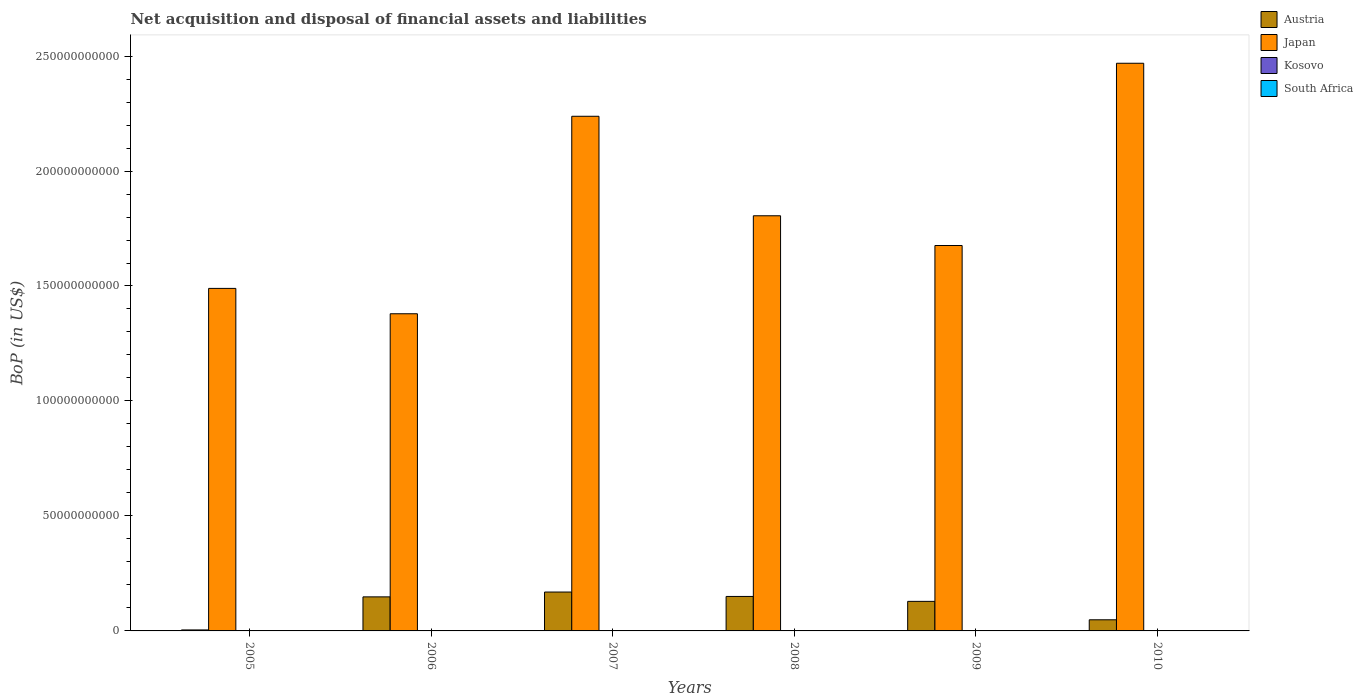How many groups of bars are there?
Give a very brief answer. 6. How many bars are there on the 3rd tick from the right?
Offer a very short reply. 2. What is the Balance of Payments in Japan in 2005?
Make the answer very short. 1.49e+11. Across all years, what is the maximum Balance of Payments in Austria?
Your response must be concise. 1.69e+1. Across all years, what is the minimum Balance of Payments in South Africa?
Provide a short and direct response. 0. In which year was the Balance of Payments in Austria maximum?
Make the answer very short. 2007. What is the total Balance of Payments in Kosovo in the graph?
Make the answer very short. 4.48e+07. What is the difference between the Balance of Payments in Japan in 2005 and that in 2009?
Your response must be concise. -1.87e+1. What is the difference between the Balance of Payments in Kosovo in 2008 and the Balance of Payments in Japan in 2006?
Your response must be concise. -1.38e+11. In the year 2006, what is the difference between the Balance of Payments in Austria and Balance of Payments in Kosovo?
Offer a very short reply. 1.48e+1. In how many years, is the Balance of Payments in Japan greater than 160000000000 US$?
Give a very brief answer. 4. What is the ratio of the Balance of Payments in Austria in 2005 to that in 2010?
Your answer should be very brief. 0.09. What is the difference between the highest and the second highest Balance of Payments in Austria?
Give a very brief answer. 1.92e+09. What is the difference between the highest and the lowest Balance of Payments in Kosovo?
Your answer should be compact. 4.48e+07. In how many years, is the Balance of Payments in Austria greater than the average Balance of Payments in Austria taken over all years?
Your answer should be compact. 4. Is it the case that in every year, the sum of the Balance of Payments in Austria and Balance of Payments in South Africa is greater than the Balance of Payments in Kosovo?
Your response must be concise. Yes. Are all the bars in the graph horizontal?
Give a very brief answer. No. How many years are there in the graph?
Your answer should be very brief. 6. Does the graph contain any zero values?
Make the answer very short. Yes. Does the graph contain grids?
Ensure brevity in your answer.  No. How many legend labels are there?
Provide a succinct answer. 4. What is the title of the graph?
Offer a terse response. Net acquisition and disposal of financial assets and liabilities. What is the label or title of the Y-axis?
Keep it short and to the point. BoP (in US$). What is the BoP (in US$) of Austria in 2005?
Provide a short and direct response. 4.32e+08. What is the BoP (in US$) of Japan in 2005?
Your answer should be very brief. 1.49e+11. What is the BoP (in US$) of South Africa in 2005?
Provide a short and direct response. 0. What is the BoP (in US$) of Austria in 2006?
Provide a succinct answer. 1.48e+1. What is the BoP (in US$) in Japan in 2006?
Your response must be concise. 1.38e+11. What is the BoP (in US$) in Kosovo in 2006?
Your response must be concise. 4.48e+07. What is the BoP (in US$) of South Africa in 2006?
Make the answer very short. 0. What is the BoP (in US$) of Austria in 2007?
Offer a terse response. 1.69e+1. What is the BoP (in US$) in Japan in 2007?
Ensure brevity in your answer.  2.24e+11. What is the BoP (in US$) of South Africa in 2007?
Offer a terse response. 0. What is the BoP (in US$) in Austria in 2008?
Give a very brief answer. 1.50e+1. What is the BoP (in US$) of Japan in 2008?
Offer a terse response. 1.81e+11. What is the BoP (in US$) in Kosovo in 2008?
Ensure brevity in your answer.  0. What is the BoP (in US$) of South Africa in 2008?
Keep it short and to the point. 0. What is the BoP (in US$) of Austria in 2009?
Your answer should be very brief. 1.29e+1. What is the BoP (in US$) in Japan in 2009?
Keep it short and to the point. 1.68e+11. What is the BoP (in US$) of Austria in 2010?
Give a very brief answer. 4.84e+09. What is the BoP (in US$) in Japan in 2010?
Provide a succinct answer. 2.47e+11. What is the BoP (in US$) of Kosovo in 2010?
Provide a succinct answer. 0. Across all years, what is the maximum BoP (in US$) of Austria?
Offer a terse response. 1.69e+1. Across all years, what is the maximum BoP (in US$) of Japan?
Your answer should be very brief. 2.47e+11. Across all years, what is the maximum BoP (in US$) of Kosovo?
Your answer should be very brief. 4.48e+07. Across all years, what is the minimum BoP (in US$) of Austria?
Provide a short and direct response. 4.32e+08. Across all years, what is the minimum BoP (in US$) of Japan?
Your response must be concise. 1.38e+11. Across all years, what is the minimum BoP (in US$) of Kosovo?
Your answer should be very brief. 0. What is the total BoP (in US$) in Austria in the graph?
Your response must be concise. 6.48e+1. What is the total BoP (in US$) of Japan in the graph?
Offer a very short reply. 1.11e+12. What is the total BoP (in US$) of Kosovo in the graph?
Your answer should be very brief. 4.48e+07. What is the difference between the BoP (in US$) of Austria in 2005 and that in 2006?
Offer a very short reply. -1.44e+1. What is the difference between the BoP (in US$) in Japan in 2005 and that in 2006?
Offer a terse response. 1.10e+1. What is the difference between the BoP (in US$) of Austria in 2005 and that in 2007?
Keep it short and to the point. -1.65e+1. What is the difference between the BoP (in US$) in Japan in 2005 and that in 2007?
Keep it short and to the point. -7.49e+1. What is the difference between the BoP (in US$) in Austria in 2005 and that in 2008?
Keep it short and to the point. -1.46e+1. What is the difference between the BoP (in US$) in Japan in 2005 and that in 2008?
Make the answer very short. -3.16e+1. What is the difference between the BoP (in US$) in Austria in 2005 and that in 2009?
Offer a terse response. -1.24e+1. What is the difference between the BoP (in US$) of Japan in 2005 and that in 2009?
Your answer should be compact. -1.87e+1. What is the difference between the BoP (in US$) of Austria in 2005 and that in 2010?
Offer a terse response. -4.41e+09. What is the difference between the BoP (in US$) of Japan in 2005 and that in 2010?
Your answer should be very brief. -9.79e+1. What is the difference between the BoP (in US$) of Austria in 2006 and that in 2007?
Make the answer very short. -2.10e+09. What is the difference between the BoP (in US$) of Japan in 2006 and that in 2007?
Your answer should be very brief. -8.59e+1. What is the difference between the BoP (in US$) of Austria in 2006 and that in 2008?
Offer a terse response. -1.83e+08. What is the difference between the BoP (in US$) of Japan in 2006 and that in 2008?
Offer a very short reply. -4.26e+1. What is the difference between the BoP (in US$) in Austria in 2006 and that in 2009?
Your response must be concise. 1.96e+09. What is the difference between the BoP (in US$) in Japan in 2006 and that in 2009?
Keep it short and to the point. -2.97e+1. What is the difference between the BoP (in US$) in Austria in 2006 and that in 2010?
Your answer should be very brief. 9.97e+09. What is the difference between the BoP (in US$) in Japan in 2006 and that in 2010?
Provide a succinct answer. -1.09e+11. What is the difference between the BoP (in US$) in Austria in 2007 and that in 2008?
Provide a short and direct response. 1.92e+09. What is the difference between the BoP (in US$) in Japan in 2007 and that in 2008?
Your response must be concise. 4.33e+1. What is the difference between the BoP (in US$) in Austria in 2007 and that in 2009?
Your response must be concise. 4.06e+09. What is the difference between the BoP (in US$) in Japan in 2007 and that in 2009?
Ensure brevity in your answer.  5.62e+1. What is the difference between the BoP (in US$) of Austria in 2007 and that in 2010?
Make the answer very short. 1.21e+1. What is the difference between the BoP (in US$) of Japan in 2007 and that in 2010?
Offer a very short reply. -2.31e+1. What is the difference between the BoP (in US$) in Austria in 2008 and that in 2009?
Offer a very short reply. 2.14e+09. What is the difference between the BoP (in US$) of Japan in 2008 and that in 2009?
Give a very brief answer. 1.29e+1. What is the difference between the BoP (in US$) of Austria in 2008 and that in 2010?
Keep it short and to the point. 1.01e+1. What is the difference between the BoP (in US$) of Japan in 2008 and that in 2010?
Offer a very short reply. -6.63e+1. What is the difference between the BoP (in US$) of Austria in 2009 and that in 2010?
Make the answer very short. 8.01e+09. What is the difference between the BoP (in US$) in Japan in 2009 and that in 2010?
Your answer should be very brief. -7.93e+1. What is the difference between the BoP (in US$) of Austria in 2005 and the BoP (in US$) of Japan in 2006?
Offer a terse response. -1.37e+11. What is the difference between the BoP (in US$) in Austria in 2005 and the BoP (in US$) in Kosovo in 2006?
Ensure brevity in your answer.  3.87e+08. What is the difference between the BoP (in US$) in Japan in 2005 and the BoP (in US$) in Kosovo in 2006?
Provide a succinct answer. 1.49e+11. What is the difference between the BoP (in US$) of Austria in 2005 and the BoP (in US$) of Japan in 2007?
Make the answer very short. -2.23e+11. What is the difference between the BoP (in US$) in Austria in 2005 and the BoP (in US$) in Japan in 2008?
Make the answer very short. -1.80e+11. What is the difference between the BoP (in US$) of Austria in 2005 and the BoP (in US$) of Japan in 2009?
Your answer should be compact. -1.67e+11. What is the difference between the BoP (in US$) in Austria in 2005 and the BoP (in US$) in Japan in 2010?
Your response must be concise. -2.46e+11. What is the difference between the BoP (in US$) of Austria in 2006 and the BoP (in US$) of Japan in 2007?
Give a very brief answer. -2.09e+11. What is the difference between the BoP (in US$) in Austria in 2006 and the BoP (in US$) in Japan in 2008?
Offer a very short reply. -1.66e+11. What is the difference between the BoP (in US$) in Austria in 2006 and the BoP (in US$) in Japan in 2009?
Give a very brief answer. -1.53e+11. What is the difference between the BoP (in US$) of Austria in 2006 and the BoP (in US$) of Japan in 2010?
Keep it short and to the point. -2.32e+11. What is the difference between the BoP (in US$) in Austria in 2007 and the BoP (in US$) in Japan in 2008?
Offer a terse response. -1.64e+11. What is the difference between the BoP (in US$) of Austria in 2007 and the BoP (in US$) of Japan in 2009?
Give a very brief answer. -1.51e+11. What is the difference between the BoP (in US$) in Austria in 2007 and the BoP (in US$) in Japan in 2010?
Your answer should be very brief. -2.30e+11. What is the difference between the BoP (in US$) of Austria in 2008 and the BoP (in US$) of Japan in 2009?
Offer a terse response. -1.53e+11. What is the difference between the BoP (in US$) in Austria in 2008 and the BoP (in US$) in Japan in 2010?
Make the answer very short. -2.32e+11. What is the difference between the BoP (in US$) in Austria in 2009 and the BoP (in US$) in Japan in 2010?
Give a very brief answer. -2.34e+11. What is the average BoP (in US$) in Austria per year?
Make the answer very short. 1.08e+1. What is the average BoP (in US$) in Japan per year?
Offer a very short reply. 1.84e+11. What is the average BoP (in US$) in Kosovo per year?
Your answer should be compact. 7.47e+06. What is the average BoP (in US$) of South Africa per year?
Your response must be concise. 0. In the year 2005, what is the difference between the BoP (in US$) in Austria and BoP (in US$) in Japan?
Your answer should be compact. -1.49e+11. In the year 2006, what is the difference between the BoP (in US$) in Austria and BoP (in US$) in Japan?
Provide a succinct answer. -1.23e+11. In the year 2006, what is the difference between the BoP (in US$) of Austria and BoP (in US$) of Kosovo?
Provide a short and direct response. 1.48e+1. In the year 2006, what is the difference between the BoP (in US$) of Japan and BoP (in US$) of Kosovo?
Make the answer very short. 1.38e+11. In the year 2007, what is the difference between the BoP (in US$) of Austria and BoP (in US$) of Japan?
Give a very brief answer. -2.07e+11. In the year 2008, what is the difference between the BoP (in US$) of Austria and BoP (in US$) of Japan?
Give a very brief answer. -1.66e+11. In the year 2009, what is the difference between the BoP (in US$) of Austria and BoP (in US$) of Japan?
Give a very brief answer. -1.55e+11. In the year 2010, what is the difference between the BoP (in US$) of Austria and BoP (in US$) of Japan?
Offer a terse response. -2.42e+11. What is the ratio of the BoP (in US$) of Austria in 2005 to that in 2006?
Make the answer very short. 0.03. What is the ratio of the BoP (in US$) in Japan in 2005 to that in 2006?
Provide a succinct answer. 1.08. What is the ratio of the BoP (in US$) in Austria in 2005 to that in 2007?
Your answer should be very brief. 0.03. What is the ratio of the BoP (in US$) in Japan in 2005 to that in 2007?
Your response must be concise. 0.67. What is the ratio of the BoP (in US$) in Austria in 2005 to that in 2008?
Offer a very short reply. 0.03. What is the ratio of the BoP (in US$) of Japan in 2005 to that in 2008?
Your answer should be compact. 0.83. What is the ratio of the BoP (in US$) in Austria in 2005 to that in 2009?
Give a very brief answer. 0.03. What is the ratio of the BoP (in US$) of Japan in 2005 to that in 2009?
Your response must be concise. 0.89. What is the ratio of the BoP (in US$) in Austria in 2005 to that in 2010?
Your response must be concise. 0.09. What is the ratio of the BoP (in US$) in Japan in 2005 to that in 2010?
Make the answer very short. 0.6. What is the ratio of the BoP (in US$) in Austria in 2006 to that in 2007?
Keep it short and to the point. 0.88. What is the ratio of the BoP (in US$) of Japan in 2006 to that in 2007?
Provide a succinct answer. 0.62. What is the ratio of the BoP (in US$) in Austria in 2006 to that in 2008?
Ensure brevity in your answer.  0.99. What is the ratio of the BoP (in US$) of Japan in 2006 to that in 2008?
Keep it short and to the point. 0.76. What is the ratio of the BoP (in US$) of Austria in 2006 to that in 2009?
Offer a terse response. 1.15. What is the ratio of the BoP (in US$) in Japan in 2006 to that in 2009?
Offer a terse response. 0.82. What is the ratio of the BoP (in US$) in Austria in 2006 to that in 2010?
Ensure brevity in your answer.  3.06. What is the ratio of the BoP (in US$) in Japan in 2006 to that in 2010?
Offer a terse response. 0.56. What is the ratio of the BoP (in US$) of Austria in 2007 to that in 2008?
Provide a succinct answer. 1.13. What is the ratio of the BoP (in US$) of Japan in 2007 to that in 2008?
Make the answer very short. 1.24. What is the ratio of the BoP (in US$) of Austria in 2007 to that in 2009?
Your response must be concise. 1.32. What is the ratio of the BoP (in US$) of Japan in 2007 to that in 2009?
Keep it short and to the point. 1.34. What is the ratio of the BoP (in US$) in Austria in 2007 to that in 2010?
Offer a very short reply. 3.49. What is the ratio of the BoP (in US$) of Japan in 2007 to that in 2010?
Keep it short and to the point. 0.91. What is the ratio of the BoP (in US$) in Austria in 2008 to that in 2009?
Offer a terse response. 1.17. What is the ratio of the BoP (in US$) of Japan in 2008 to that in 2009?
Keep it short and to the point. 1.08. What is the ratio of the BoP (in US$) in Austria in 2008 to that in 2010?
Offer a very short reply. 3.1. What is the ratio of the BoP (in US$) in Japan in 2008 to that in 2010?
Make the answer very short. 0.73. What is the ratio of the BoP (in US$) of Austria in 2009 to that in 2010?
Offer a terse response. 2.65. What is the ratio of the BoP (in US$) of Japan in 2009 to that in 2010?
Offer a very short reply. 0.68. What is the difference between the highest and the second highest BoP (in US$) in Austria?
Offer a terse response. 1.92e+09. What is the difference between the highest and the second highest BoP (in US$) of Japan?
Provide a succinct answer. 2.31e+1. What is the difference between the highest and the lowest BoP (in US$) of Austria?
Your answer should be compact. 1.65e+1. What is the difference between the highest and the lowest BoP (in US$) of Japan?
Your answer should be very brief. 1.09e+11. What is the difference between the highest and the lowest BoP (in US$) in Kosovo?
Offer a very short reply. 4.48e+07. 